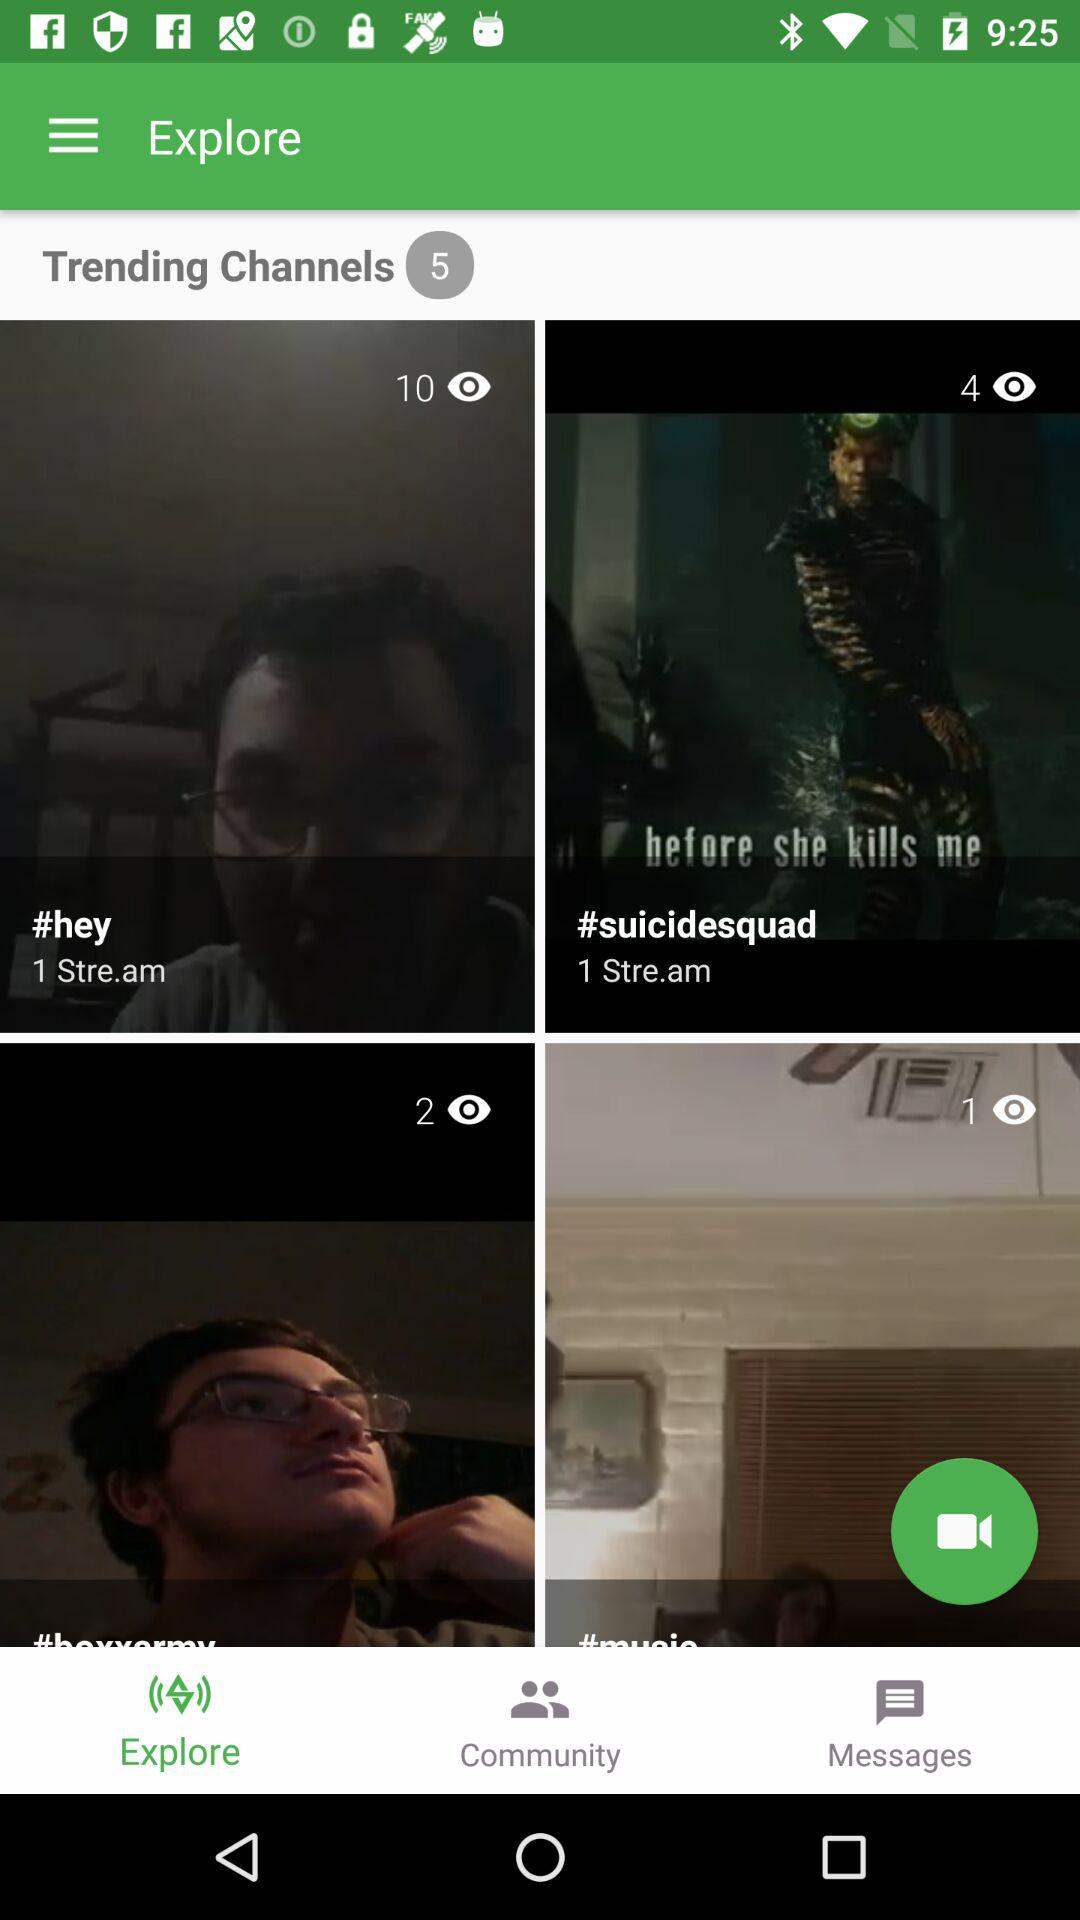How many viewers are watching the live stream of "#hey"? The number of viewers is 10. 